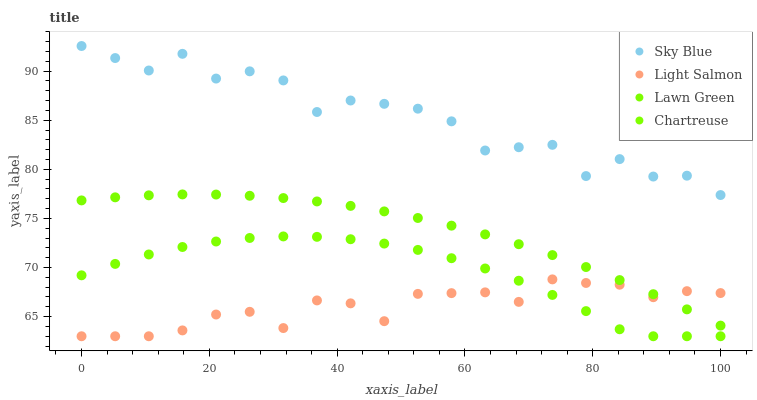Does Light Salmon have the minimum area under the curve?
Answer yes or no. Yes. Does Sky Blue have the maximum area under the curve?
Answer yes or no. Yes. Does Chartreuse have the minimum area under the curve?
Answer yes or no. No. Does Chartreuse have the maximum area under the curve?
Answer yes or no. No. Is Lawn Green the smoothest?
Answer yes or no. Yes. Is Sky Blue the roughest?
Answer yes or no. Yes. Is Light Salmon the smoothest?
Answer yes or no. No. Is Light Salmon the roughest?
Answer yes or no. No. Does Light Salmon have the lowest value?
Answer yes or no. Yes. Does Lawn Green have the lowest value?
Answer yes or no. No. Does Sky Blue have the highest value?
Answer yes or no. Yes. Does Chartreuse have the highest value?
Answer yes or no. No. Is Chartreuse less than Sky Blue?
Answer yes or no. Yes. Is Lawn Green greater than Chartreuse?
Answer yes or no. Yes. Does Light Salmon intersect Lawn Green?
Answer yes or no. Yes. Is Light Salmon less than Lawn Green?
Answer yes or no. No. Is Light Salmon greater than Lawn Green?
Answer yes or no. No. Does Chartreuse intersect Sky Blue?
Answer yes or no. No. 